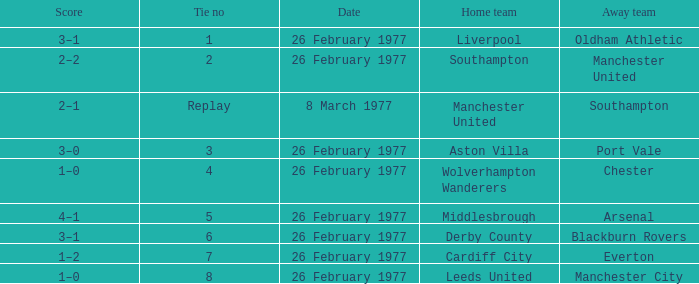What's the score when the draw number was 6? 3–1. 